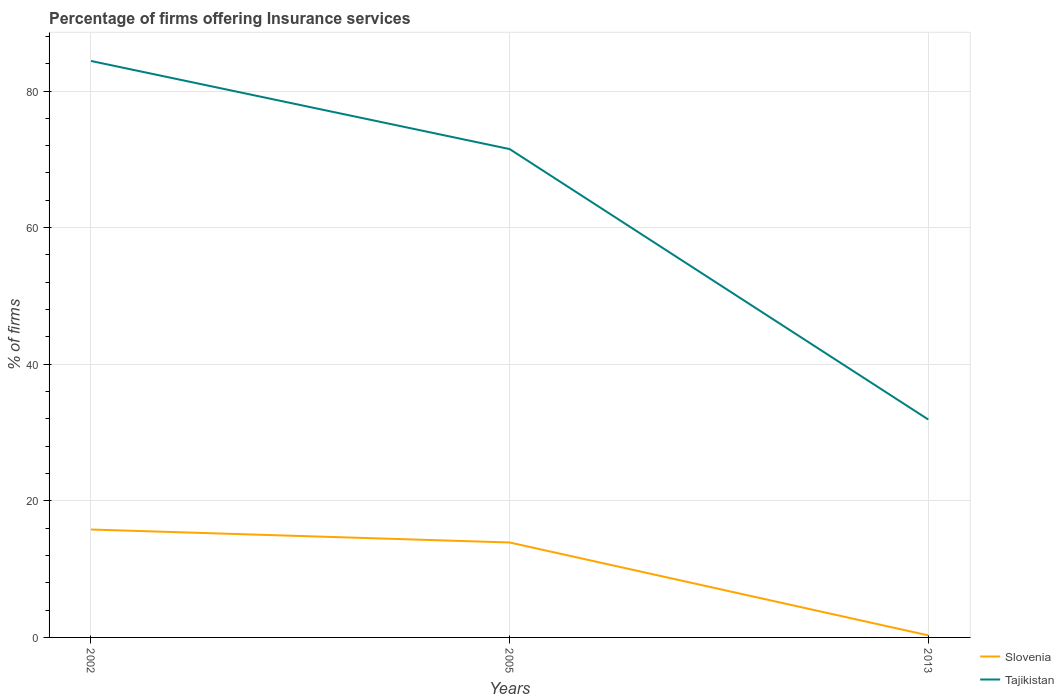How many different coloured lines are there?
Your answer should be very brief. 2. Does the line corresponding to Tajikistan intersect with the line corresponding to Slovenia?
Your answer should be very brief. No. Is the number of lines equal to the number of legend labels?
Ensure brevity in your answer.  Yes. Across all years, what is the maximum percentage of firms offering insurance services in Tajikistan?
Your answer should be compact. 31.9. What is the total percentage of firms offering insurance services in Tajikistan in the graph?
Your answer should be compact. 12.9. What is the difference between the highest and the second highest percentage of firms offering insurance services in Tajikistan?
Offer a terse response. 52.5. How many years are there in the graph?
Give a very brief answer. 3. Does the graph contain grids?
Your answer should be compact. Yes. Where does the legend appear in the graph?
Give a very brief answer. Bottom right. What is the title of the graph?
Your answer should be compact. Percentage of firms offering Insurance services. Does "North America" appear as one of the legend labels in the graph?
Make the answer very short. No. What is the label or title of the X-axis?
Ensure brevity in your answer.  Years. What is the label or title of the Y-axis?
Ensure brevity in your answer.  % of firms. What is the % of firms of Tajikistan in 2002?
Your answer should be compact. 84.4. What is the % of firms in Slovenia in 2005?
Your response must be concise. 13.9. What is the % of firms in Tajikistan in 2005?
Give a very brief answer. 71.5. What is the % of firms of Tajikistan in 2013?
Offer a terse response. 31.9. Across all years, what is the maximum % of firms of Slovenia?
Give a very brief answer. 15.8. Across all years, what is the maximum % of firms in Tajikistan?
Your answer should be compact. 84.4. Across all years, what is the minimum % of firms in Tajikistan?
Ensure brevity in your answer.  31.9. What is the total % of firms of Slovenia in the graph?
Your answer should be very brief. 30. What is the total % of firms in Tajikistan in the graph?
Your answer should be very brief. 187.8. What is the difference between the % of firms of Slovenia in 2002 and that in 2005?
Provide a short and direct response. 1.9. What is the difference between the % of firms in Tajikistan in 2002 and that in 2013?
Your answer should be very brief. 52.5. What is the difference between the % of firms in Tajikistan in 2005 and that in 2013?
Your answer should be very brief. 39.6. What is the difference between the % of firms of Slovenia in 2002 and the % of firms of Tajikistan in 2005?
Make the answer very short. -55.7. What is the difference between the % of firms of Slovenia in 2002 and the % of firms of Tajikistan in 2013?
Ensure brevity in your answer.  -16.1. What is the difference between the % of firms of Slovenia in 2005 and the % of firms of Tajikistan in 2013?
Give a very brief answer. -18. What is the average % of firms in Slovenia per year?
Your response must be concise. 10. What is the average % of firms in Tajikistan per year?
Your response must be concise. 62.6. In the year 2002, what is the difference between the % of firms in Slovenia and % of firms in Tajikistan?
Your answer should be compact. -68.6. In the year 2005, what is the difference between the % of firms of Slovenia and % of firms of Tajikistan?
Your answer should be very brief. -57.6. In the year 2013, what is the difference between the % of firms of Slovenia and % of firms of Tajikistan?
Offer a very short reply. -31.6. What is the ratio of the % of firms of Slovenia in 2002 to that in 2005?
Keep it short and to the point. 1.14. What is the ratio of the % of firms of Tajikistan in 2002 to that in 2005?
Give a very brief answer. 1.18. What is the ratio of the % of firms of Slovenia in 2002 to that in 2013?
Offer a terse response. 52.67. What is the ratio of the % of firms in Tajikistan in 2002 to that in 2013?
Your response must be concise. 2.65. What is the ratio of the % of firms in Slovenia in 2005 to that in 2013?
Offer a terse response. 46.33. What is the ratio of the % of firms in Tajikistan in 2005 to that in 2013?
Provide a short and direct response. 2.24. What is the difference between the highest and the second highest % of firms in Tajikistan?
Your answer should be compact. 12.9. What is the difference between the highest and the lowest % of firms in Slovenia?
Keep it short and to the point. 15.5. What is the difference between the highest and the lowest % of firms of Tajikistan?
Keep it short and to the point. 52.5. 